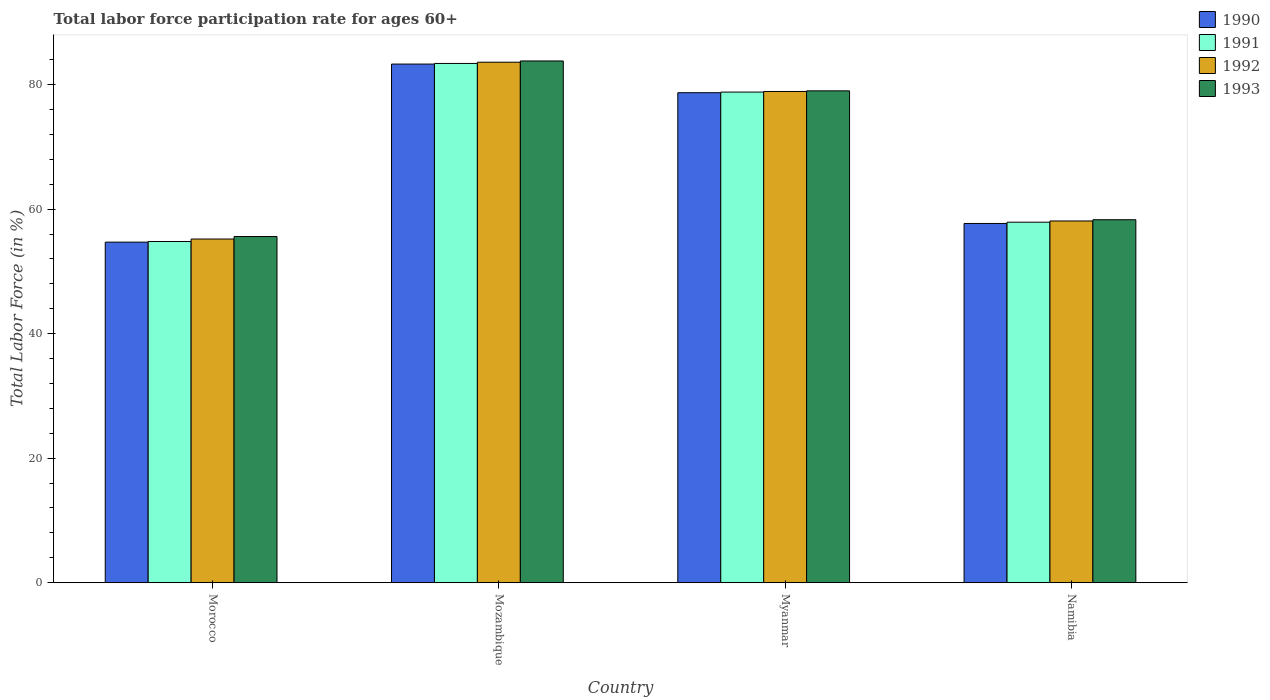How many different coloured bars are there?
Your answer should be compact. 4. Are the number of bars per tick equal to the number of legend labels?
Offer a terse response. Yes. What is the label of the 4th group of bars from the left?
Your answer should be very brief. Namibia. What is the labor force participation rate in 1992 in Myanmar?
Your response must be concise. 78.9. Across all countries, what is the maximum labor force participation rate in 1991?
Give a very brief answer. 83.4. Across all countries, what is the minimum labor force participation rate in 1993?
Your answer should be compact. 55.6. In which country was the labor force participation rate in 1991 maximum?
Ensure brevity in your answer.  Mozambique. In which country was the labor force participation rate in 1992 minimum?
Your response must be concise. Morocco. What is the total labor force participation rate in 1991 in the graph?
Offer a terse response. 274.9. What is the difference between the labor force participation rate in 1991 in Mozambique and that in Namibia?
Give a very brief answer. 25.5. What is the difference between the labor force participation rate in 1991 in Morocco and the labor force participation rate in 1992 in Namibia?
Ensure brevity in your answer.  -3.3. What is the average labor force participation rate in 1993 per country?
Give a very brief answer. 69.18. What is the difference between the labor force participation rate of/in 1990 and labor force participation rate of/in 1993 in Morocco?
Your answer should be compact. -0.9. In how many countries, is the labor force participation rate in 1992 greater than 32 %?
Your answer should be very brief. 4. What is the ratio of the labor force participation rate in 1993 in Morocco to that in Namibia?
Your response must be concise. 0.95. Is the labor force participation rate in 1993 in Mozambique less than that in Namibia?
Offer a very short reply. No. Is the difference between the labor force participation rate in 1990 in Morocco and Mozambique greater than the difference between the labor force participation rate in 1993 in Morocco and Mozambique?
Provide a short and direct response. No. What is the difference between the highest and the second highest labor force participation rate in 1991?
Ensure brevity in your answer.  -25.5. What is the difference between the highest and the lowest labor force participation rate in 1992?
Provide a short and direct response. 28.4. In how many countries, is the labor force participation rate in 1992 greater than the average labor force participation rate in 1992 taken over all countries?
Your response must be concise. 2. Is the sum of the labor force participation rate in 1992 in Mozambique and Namibia greater than the maximum labor force participation rate in 1993 across all countries?
Make the answer very short. Yes. Is it the case that in every country, the sum of the labor force participation rate in 1991 and labor force participation rate in 1992 is greater than the sum of labor force participation rate in 1993 and labor force participation rate in 1990?
Ensure brevity in your answer.  No. How many bars are there?
Offer a very short reply. 16. Are all the bars in the graph horizontal?
Keep it short and to the point. No. What is the difference between two consecutive major ticks on the Y-axis?
Offer a very short reply. 20. Does the graph contain any zero values?
Your answer should be very brief. No. Does the graph contain grids?
Offer a very short reply. No. How many legend labels are there?
Keep it short and to the point. 4. What is the title of the graph?
Provide a short and direct response. Total labor force participation rate for ages 60+. Does "1968" appear as one of the legend labels in the graph?
Your answer should be very brief. No. What is the label or title of the Y-axis?
Give a very brief answer. Total Labor Force (in %). What is the Total Labor Force (in %) of 1990 in Morocco?
Make the answer very short. 54.7. What is the Total Labor Force (in %) in 1991 in Morocco?
Offer a terse response. 54.8. What is the Total Labor Force (in %) in 1992 in Morocco?
Offer a very short reply. 55.2. What is the Total Labor Force (in %) of 1993 in Morocco?
Provide a short and direct response. 55.6. What is the Total Labor Force (in %) in 1990 in Mozambique?
Give a very brief answer. 83.3. What is the Total Labor Force (in %) of 1991 in Mozambique?
Ensure brevity in your answer.  83.4. What is the Total Labor Force (in %) in 1992 in Mozambique?
Offer a very short reply. 83.6. What is the Total Labor Force (in %) in 1993 in Mozambique?
Give a very brief answer. 83.8. What is the Total Labor Force (in %) of 1990 in Myanmar?
Offer a very short reply. 78.7. What is the Total Labor Force (in %) in 1991 in Myanmar?
Your answer should be very brief. 78.8. What is the Total Labor Force (in %) in 1992 in Myanmar?
Your answer should be compact. 78.9. What is the Total Labor Force (in %) in 1993 in Myanmar?
Ensure brevity in your answer.  79. What is the Total Labor Force (in %) in 1990 in Namibia?
Make the answer very short. 57.7. What is the Total Labor Force (in %) in 1991 in Namibia?
Provide a short and direct response. 57.9. What is the Total Labor Force (in %) of 1992 in Namibia?
Ensure brevity in your answer.  58.1. What is the Total Labor Force (in %) in 1993 in Namibia?
Provide a short and direct response. 58.3. Across all countries, what is the maximum Total Labor Force (in %) in 1990?
Your answer should be very brief. 83.3. Across all countries, what is the maximum Total Labor Force (in %) of 1991?
Provide a short and direct response. 83.4. Across all countries, what is the maximum Total Labor Force (in %) of 1992?
Ensure brevity in your answer.  83.6. Across all countries, what is the maximum Total Labor Force (in %) of 1993?
Give a very brief answer. 83.8. Across all countries, what is the minimum Total Labor Force (in %) of 1990?
Your response must be concise. 54.7. Across all countries, what is the minimum Total Labor Force (in %) of 1991?
Give a very brief answer. 54.8. Across all countries, what is the minimum Total Labor Force (in %) of 1992?
Your answer should be compact. 55.2. Across all countries, what is the minimum Total Labor Force (in %) in 1993?
Provide a succinct answer. 55.6. What is the total Total Labor Force (in %) in 1990 in the graph?
Your answer should be very brief. 274.4. What is the total Total Labor Force (in %) in 1991 in the graph?
Offer a terse response. 274.9. What is the total Total Labor Force (in %) of 1992 in the graph?
Offer a very short reply. 275.8. What is the total Total Labor Force (in %) of 1993 in the graph?
Offer a terse response. 276.7. What is the difference between the Total Labor Force (in %) in 1990 in Morocco and that in Mozambique?
Your answer should be very brief. -28.6. What is the difference between the Total Labor Force (in %) of 1991 in Morocco and that in Mozambique?
Your answer should be very brief. -28.6. What is the difference between the Total Labor Force (in %) of 1992 in Morocco and that in Mozambique?
Offer a terse response. -28.4. What is the difference between the Total Labor Force (in %) in 1993 in Morocco and that in Mozambique?
Keep it short and to the point. -28.2. What is the difference between the Total Labor Force (in %) in 1991 in Morocco and that in Myanmar?
Your answer should be very brief. -24. What is the difference between the Total Labor Force (in %) in 1992 in Morocco and that in Myanmar?
Make the answer very short. -23.7. What is the difference between the Total Labor Force (in %) in 1993 in Morocco and that in Myanmar?
Your answer should be very brief. -23.4. What is the difference between the Total Labor Force (in %) in 1990 in Morocco and that in Namibia?
Keep it short and to the point. -3. What is the difference between the Total Labor Force (in %) in 1991 in Morocco and that in Namibia?
Your answer should be very brief. -3.1. What is the difference between the Total Labor Force (in %) of 1992 in Morocco and that in Namibia?
Provide a succinct answer. -2.9. What is the difference between the Total Labor Force (in %) of 1991 in Mozambique and that in Myanmar?
Provide a short and direct response. 4.6. What is the difference between the Total Labor Force (in %) in 1992 in Mozambique and that in Myanmar?
Make the answer very short. 4.7. What is the difference between the Total Labor Force (in %) in 1990 in Mozambique and that in Namibia?
Your response must be concise. 25.6. What is the difference between the Total Labor Force (in %) of 1992 in Mozambique and that in Namibia?
Your response must be concise. 25.5. What is the difference between the Total Labor Force (in %) in 1993 in Mozambique and that in Namibia?
Offer a very short reply. 25.5. What is the difference between the Total Labor Force (in %) of 1990 in Myanmar and that in Namibia?
Keep it short and to the point. 21. What is the difference between the Total Labor Force (in %) of 1991 in Myanmar and that in Namibia?
Your answer should be very brief. 20.9. What is the difference between the Total Labor Force (in %) in 1992 in Myanmar and that in Namibia?
Provide a short and direct response. 20.8. What is the difference between the Total Labor Force (in %) of 1993 in Myanmar and that in Namibia?
Offer a terse response. 20.7. What is the difference between the Total Labor Force (in %) in 1990 in Morocco and the Total Labor Force (in %) in 1991 in Mozambique?
Give a very brief answer. -28.7. What is the difference between the Total Labor Force (in %) of 1990 in Morocco and the Total Labor Force (in %) of 1992 in Mozambique?
Offer a very short reply. -28.9. What is the difference between the Total Labor Force (in %) in 1990 in Morocco and the Total Labor Force (in %) in 1993 in Mozambique?
Provide a succinct answer. -29.1. What is the difference between the Total Labor Force (in %) of 1991 in Morocco and the Total Labor Force (in %) of 1992 in Mozambique?
Keep it short and to the point. -28.8. What is the difference between the Total Labor Force (in %) of 1992 in Morocco and the Total Labor Force (in %) of 1993 in Mozambique?
Ensure brevity in your answer.  -28.6. What is the difference between the Total Labor Force (in %) of 1990 in Morocco and the Total Labor Force (in %) of 1991 in Myanmar?
Offer a very short reply. -24.1. What is the difference between the Total Labor Force (in %) in 1990 in Morocco and the Total Labor Force (in %) in 1992 in Myanmar?
Make the answer very short. -24.2. What is the difference between the Total Labor Force (in %) of 1990 in Morocco and the Total Labor Force (in %) of 1993 in Myanmar?
Ensure brevity in your answer.  -24.3. What is the difference between the Total Labor Force (in %) of 1991 in Morocco and the Total Labor Force (in %) of 1992 in Myanmar?
Your answer should be very brief. -24.1. What is the difference between the Total Labor Force (in %) in 1991 in Morocco and the Total Labor Force (in %) in 1993 in Myanmar?
Offer a terse response. -24.2. What is the difference between the Total Labor Force (in %) of 1992 in Morocco and the Total Labor Force (in %) of 1993 in Myanmar?
Your answer should be compact. -23.8. What is the difference between the Total Labor Force (in %) in 1990 in Morocco and the Total Labor Force (in %) in 1993 in Namibia?
Provide a short and direct response. -3.6. What is the difference between the Total Labor Force (in %) in 1991 in Morocco and the Total Labor Force (in %) in 1993 in Namibia?
Offer a terse response. -3.5. What is the difference between the Total Labor Force (in %) in 1992 in Morocco and the Total Labor Force (in %) in 1993 in Namibia?
Offer a very short reply. -3.1. What is the difference between the Total Labor Force (in %) of 1990 in Mozambique and the Total Labor Force (in %) of 1992 in Myanmar?
Offer a very short reply. 4.4. What is the difference between the Total Labor Force (in %) of 1990 in Mozambique and the Total Labor Force (in %) of 1993 in Myanmar?
Make the answer very short. 4.3. What is the difference between the Total Labor Force (in %) in 1990 in Mozambique and the Total Labor Force (in %) in 1991 in Namibia?
Offer a very short reply. 25.4. What is the difference between the Total Labor Force (in %) in 1990 in Mozambique and the Total Labor Force (in %) in 1992 in Namibia?
Make the answer very short. 25.2. What is the difference between the Total Labor Force (in %) in 1991 in Mozambique and the Total Labor Force (in %) in 1992 in Namibia?
Your answer should be very brief. 25.3. What is the difference between the Total Labor Force (in %) of 1991 in Mozambique and the Total Labor Force (in %) of 1993 in Namibia?
Provide a short and direct response. 25.1. What is the difference between the Total Labor Force (in %) of 1992 in Mozambique and the Total Labor Force (in %) of 1993 in Namibia?
Provide a succinct answer. 25.3. What is the difference between the Total Labor Force (in %) of 1990 in Myanmar and the Total Labor Force (in %) of 1991 in Namibia?
Your response must be concise. 20.8. What is the difference between the Total Labor Force (in %) in 1990 in Myanmar and the Total Labor Force (in %) in 1992 in Namibia?
Offer a very short reply. 20.6. What is the difference between the Total Labor Force (in %) of 1990 in Myanmar and the Total Labor Force (in %) of 1993 in Namibia?
Make the answer very short. 20.4. What is the difference between the Total Labor Force (in %) in 1991 in Myanmar and the Total Labor Force (in %) in 1992 in Namibia?
Keep it short and to the point. 20.7. What is the difference between the Total Labor Force (in %) in 1991 in Myanmar and the Total Labor Force (in %) in 1993 in Namibia?
Offer a very short reply. 20.5. What is the difference between the Total Labor Force (in %) of 1992 in Myanmar and the Total Labor Force (in %) of 1993 in Namibia?
Offer a very short reply. 20.6. What is the average Total Labor Force (in %) of 1990 per country?
Make the answer very short. 68.6. What is the average Total Labor Force (in %) in 1991 per country?
Keep it short and to the point. 68.72. What is the average Total Labor Force (in %) of 1992 per country?
Make the answer very short. 68.95. What is the average Total Labor Force (in %) in 1993 per country?
Keep it short and to the point. 69.17. What is the difference between the Total Labor Force (in %) of 1990 and Total Labor Force (in %) of 1992 in Morocco?
Offer a terse response. -0.5. What is the difference between the Total Labor Force (in %) of 1991 and Total Labor Force (in %) of 1992 in Morocco?
Offer a terse response. -0.4. What is the difference between the Total Labor Force (in %) of 1991 and Total Labor Force (in %) of 1993 in Morocco?
Your response must be concise. -0.8. What is the difference between the Total Labor Force (in %) of 1992 and Total Labor Force (in %) of 1993 in Morocco?
Provide a succinct answer. -0.4. What is the difference between the Total Labor Force (in %) in 1990 and Total Labor Force (in %) in 1991 in Mozambique?
Provide a succinct answer. -0.1. What is the difference between the Total Labor Force (in %) in 1990 and Total Labor Force (in %) in 1992 in Mozambique?
Give a very brief answer. -0.3. What is the difference between the Total Labor Force (in %) in 1991 and Total Labor Force (in %) in 1992 in Mozambique?
Make the answer very short. -0.2. What is the difference between the Total Labor Force (in %) of 1991 and Total Labor Force (in %) of 1993 in Mozambique?
Keep it short and to the point. -0.4. What is the difference between the Total Labor Force (in %) in 1990 and Total Labor Force (in %) in 1992 in Myanmar?
Make the answer very short. -0.2. What is the difference between the Total Labor Force (in %) in 1990 and Total Labor Force (in %) in 1993 in Myanmar?
Your answer should be compact. -0.3. What is the difference between the Total Labor Force (in %) of 1991 and Total Labor Force (in %) of 1992 in Myanmar?
Keep it short and to the point. -0.1. What is the difference between the Total Labor Force (in %) of 1990 and Total Labor Force (in %) of 1991 in Namibia?
Your answer should be compact. -0.2. What is the difference between the Total Labor Force (in %) in 1990 and Total Labor Force (in %) in 1992 in Namibia?
Offer a very short reply. -0.4. What is the ratio of the Total Labor Force (in %) of 1990 in Morocco to that in Mozambique?
Your answer should be very brief. 0.66. What is the ratio of the Total Labor Force (in %) in 1991 in Morocco to that in Mozambique?
Make the answer very short. 0.66. What is the ratio of the Total Labor Force (in %) in 1992 in Morocco to that in Mozambique?
Your answer should be compact. 0.66. What is the ratio of the Total Labor Force (in %) of 1993 in Morocco to that in Mozambique?
Give a very brief answer. 0.66. What is the ratio of the Total Labor Force (in %) in 1990 in Morocco to that in Myanmar?
Your response must be concise. 0.69. What is the ratio of the Total Labor Force (in %) of 1991 in Morocco to that in Myanmar?
Your response must be concise. 0.7. What is the ratio of the Total Labor Force (in %) of 1992 in Morocco to that in Myanmar?
Your answer should be compact. 0.7. What is the ratio of the Total Labor Force (in %) of 1993 in Morocco to that in Myanmar?
Provide a short and direct response. 0.7. What is the ratio of the Total Labor Force (in %) of 1990 in Morocco to that in Namibia?
Your answer should be very brief. 0.95. What is the ratio of the Total Labor Force (in %) of 1991 in Morocco to that in Namibia?
Give a very brief answer. 0.95. What is the ratio of the Total Labor Force (in %) of 1992 in Morocco to that in Namibia?
Ensure brevity in your answer.  0.95. What is the ratio of the Total Labor Force (in %) in 1993 in Morocco to that in Namibia?
Give a very brief answer. 0.95. What is the ratio of the Total Labor Force (in %) of 1990 in Mozambique to that in Myanmar?
Give a very brief answer. 1.06. What is the ratio of the Total Labor Force (in %) in 1991 in Mozambique to that in Myanmar?
Provide a succinct answer. 1.06. What is the ratio of the Total Labor Force (in %) in 1992 in Mozambique to that in Myanmar?
Make the answer very short. 1.06. What is the ratio of the Total Labor Force (in %) in 1993 in Mozambique to that in Myanmar?
Provide a succinct answer. 1.06. What is the ratio of the Total Labor Force (in %) of 1990 in Mozambique to that in Namibia?
Make the answer very short. 1.44. What is the ratio of the Total Labor Force (in %) in 1991 in Mozambique to that in Namibia?
Provide a succinct answer. 1.44. What is the ratio of the Total Labor Force (in %) of 1992 in Mozambique to that in Namibia?
Make the answer very short. 1.44. What is the ratio of the Total Labor Force (in %) in 1993 in Mozambique to that in Namibia?
Provide a succinct answer. 1.44. What is the ratio of the Total Labor Force (in %) in 1990 in Myanmar to that in Namibia?
Ensure brevity in your answer.  1.36. What is the ratio of the Total Labor Force (in %) in 1991 in Myanmar to that in Namibia?
Your response must be concise. 1.36. What is the ratio of the Total Labor Force (in %) in 1992 in Myanmar to that in Namibia?
Provide a short and direct response. 1.36. What is the ratio of the Total Labor Force (in %) in 1993 in Myanmar to that in Namibia?
Offer a terse response. 1.36. What is the difference between the highest and the second highest Total Labor Force (in %) of 1992?
Provide a short and direct response. 4.7. What is the difference between the highest and the lowest Total Labor Force (in %) of 1990?
Your answer should be very brief. 28.6. What is the difference between the highest and the lowest Total Labor Force (in %) of 1991?
Provide a short and direct response. 28.6. What is the difference between the highest and the lowest Total Labor Force (in %) of 1992?
Give a very brief answer. 28.4. What is the difference between the highest and the lowest Total Labor Force (in %) of 1993?
Your response must be concise. 28.2. 